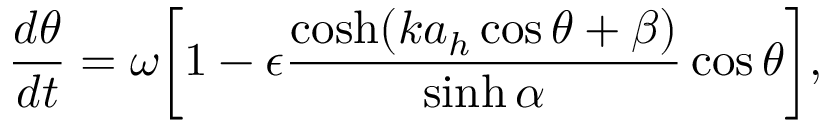Convert formula to latex. <formula><loc_0><loc_0><loc_500><loc_500>\frac { d \theta } { d t } = \omega \left [ 1 - \epsilon \frac { \cosh ( k a _ { h } \cos \theta + \beta ) } { \sinh \alpha } \cos \theta \right ] ,</formula> 